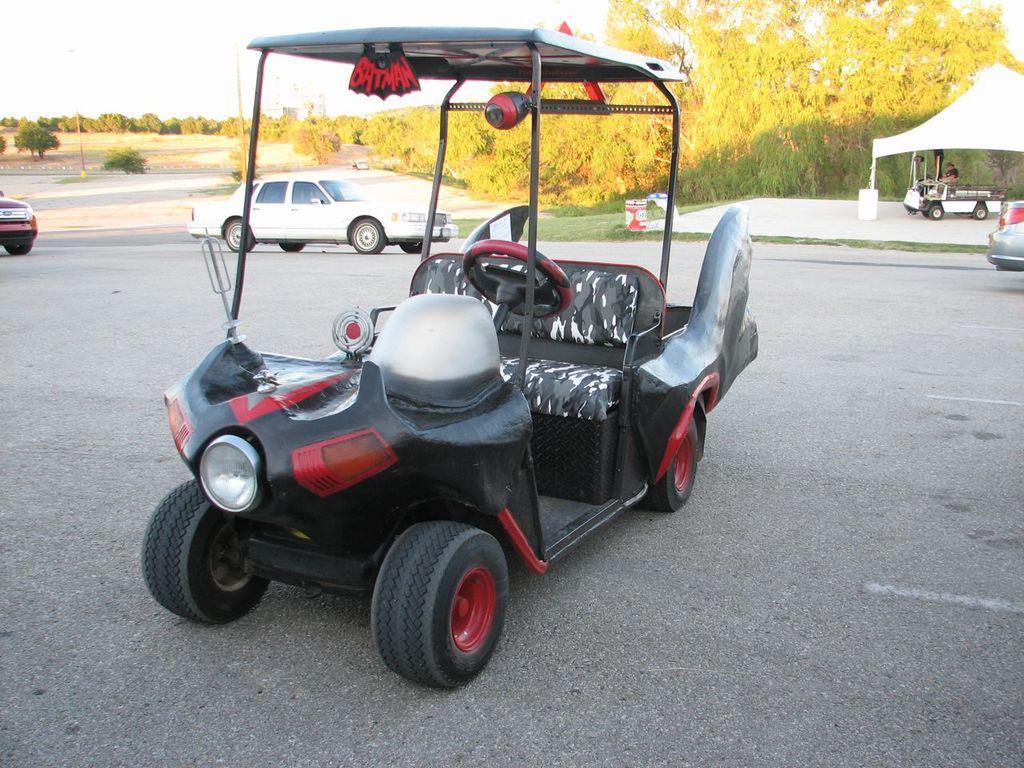In one or two sentences, can you explain what this image depicts? In this image, we can see vehicles and in the background, there are trees and poles. On the right, we can see a shed. 